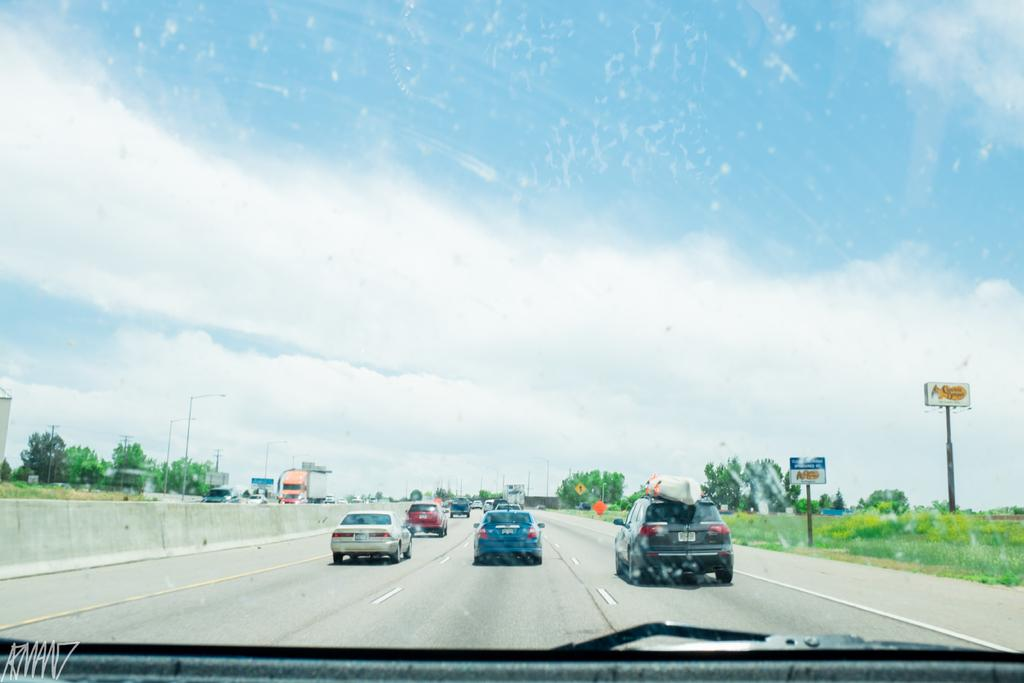What can be seen on the road in the image? There are cars on the road in the image. What is visible in the foreground of the image? There is grassland in the foreground of the image. What is visible in the background of the image? There are trees, poles, vehicles, and the sky visible in the background of the image. Can you describe the position of the car in the image? It appears that there is a car at the bottom side of the image. What type of cream can be seen on the grassland in the image? There is no cream present on the grassland in the image. Can you touch the basket that is hanging from the tree in the image? There is no basket hanging from a tree in the image. 